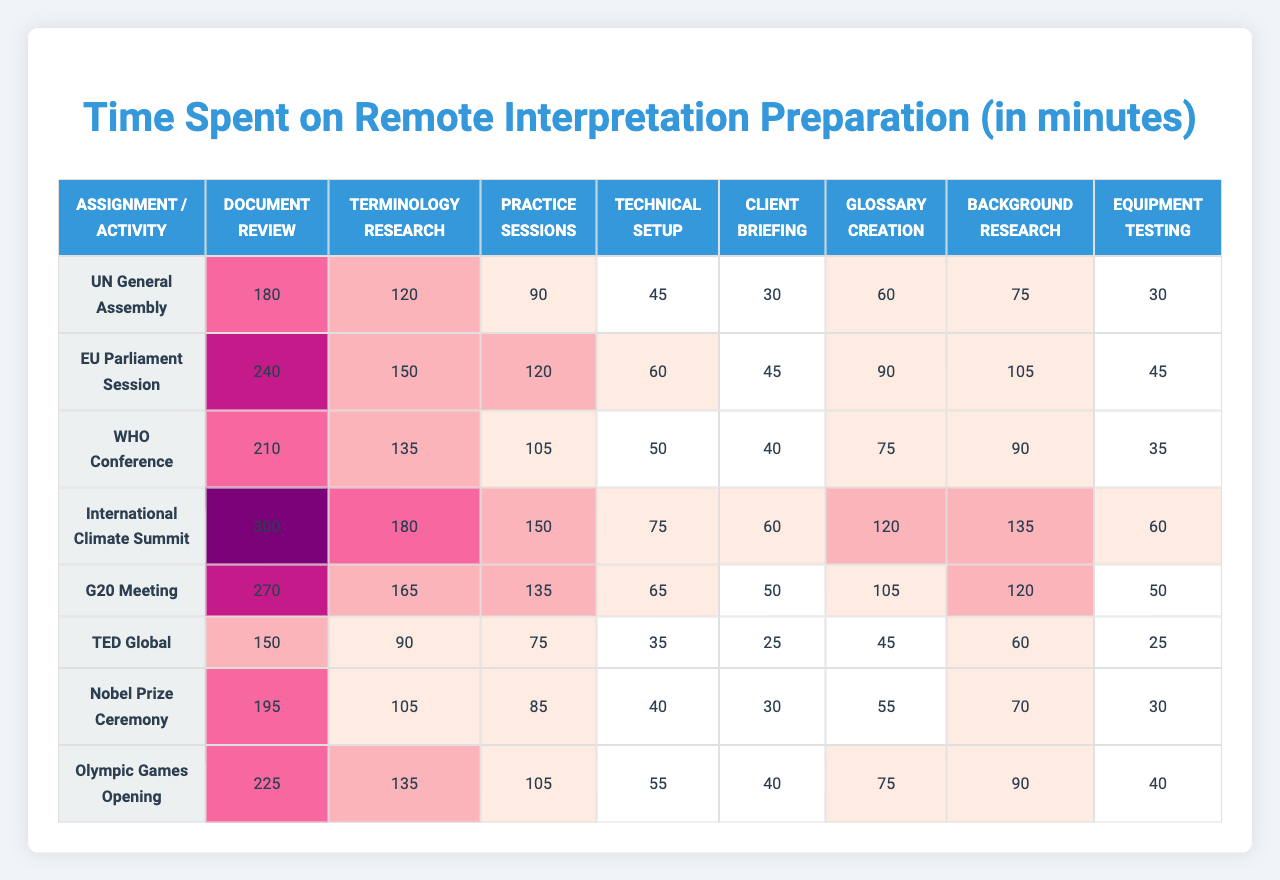How much time was spent on Document Review for the G20 Meeting? The table shows that for the G20 Meeting, the time spent on Document Review is listed as 270 minutes.
Answer: 270 minutes What is the total time spent on all preparation activities for the International Climate Summit? To find the total time for the International Climate Summit, we add all the values in that row: 300 + 180 + 150 + 75 + 60 + 120 + 135 + 60 = 1080 minutes.
Answer: 1080 minutes Is the time spent on Practice Sessions for the Nobel Prize Ceremony greater than that for the TED Global? The Nobel Prize Ceremony has 85 minutes for Practice Sessions, while TED Global has 75 minutes. Since 85 is greater than 75, the statement is true.
Answer: Yes Which activity took the most time in the WHO Conference? Looking at the WHO Conference row, the highest time spent is 210 minutes on Document Review.
Answer: Document Review Calculate the average time spent on Technical Setup across all assignments. The total time spent on Technical Setup is 45 + 60 + 50 + 75 + 65 + 35 + 40 + 55 = 425 minutes. There are 8 assignments, thus the average is 425 / 8 = 53.125 minutes.
Answer: 53.125 minutes For which assignment was the least time spent on Glossary Creation? In the table, the least time spent on Glossary Creation is for the TED Global, which shows 25 minutes.
Answer: TED Global How much more time was spent on terminology research for the EU Parliament Session than for the Olympic Games Opening? For the EU Parliament Session, the time for terminology research is 150 minutes, while for the Olympic Games Opening, it is 135 minutes. The difference is 150 - 135 = 15 minutes.
Answer: 15 minutes Identify the assignment where the time spent on Background Research is the highest. By examining the Background Research column, we see that the International Climate Summit row has the highest at 135 minutes.
Answer: International Climate Summit What is the total time spent on all activities for the UN General Assembly, and how does it compare to the time spent on the EU Parliament Session? The total time for the UN General Assembly is 180 + 120 + 90 + 45 + 30 + 60 + 75 + 30 = 630 minutes. For the EU Parliament Session, the total is 240 + 150 + 120 + 60 + 45 + 90 + 105 + 45 = 855 minutes. Thus, the EU Parliament Session took 225 minutes more.
Answer: 225 minutes more In terms of preparation activities, which assignment requires the least overall time spent? Comparing the total times spent across all assignments, TED Global has the least total time of 385 minutes.
Answer: TED Global 